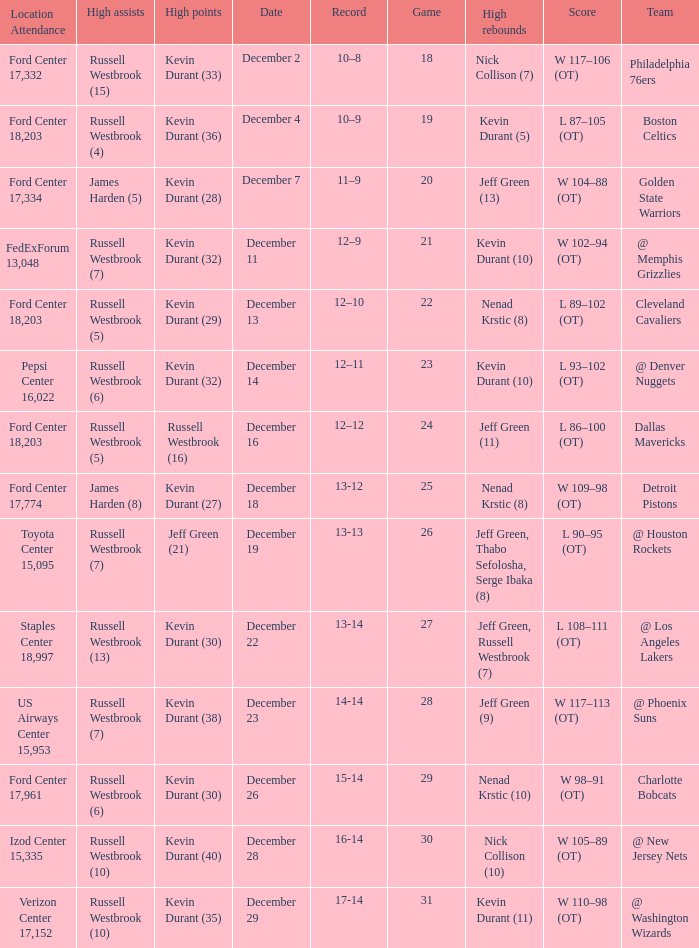Who has high points when verizon center 17,152 is location attendance? Kevin Durant (35). 